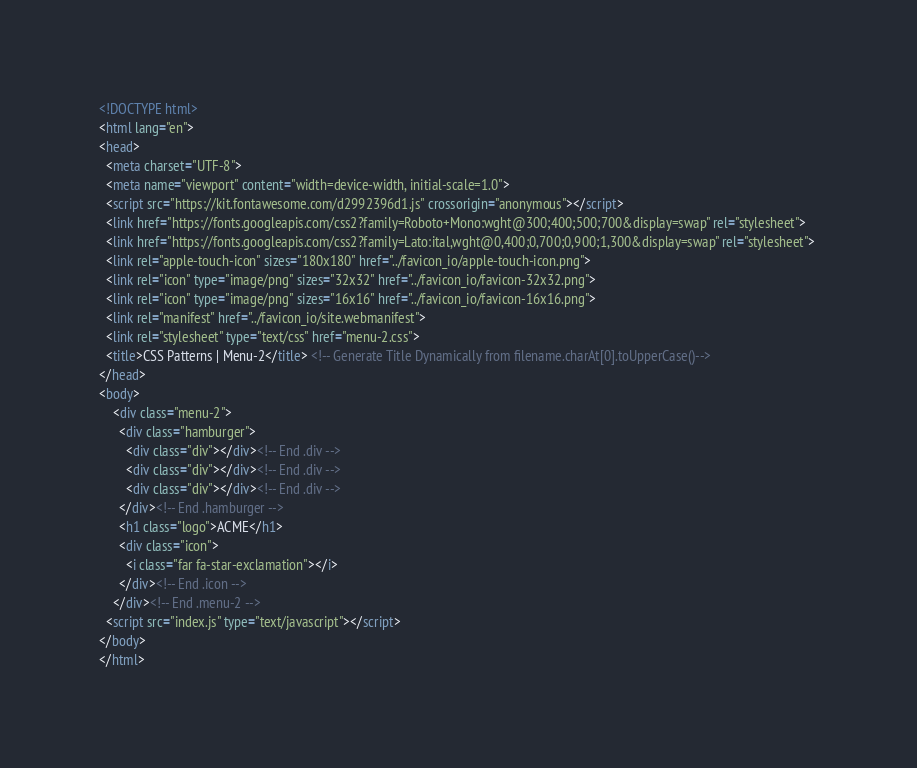<code> <loc_0><loc_0><loc_500><loc_500><_HTML_><!DOCTYPE html>
<html lang="en">
<head>
  <meta charset="UTF-8">
  <meta name="viewport" content="width=device-width, initial-scale=1.0">
  <script src="https://kit.fontawesome.com/d2992396d1.js" crossorigin="anonymous"></script>
  <link href="https://fonts.googleapis.com/css2?family=Roboto+Mono:wght@300;400;500;700&display=swap" rel="stylesheet">
  <link href="https://fonts.googleapis.com/css2?family=Lato:ital,wght@0,400;0,700;0,900;1,300&display=swap" rel="stylesheet"> 
  <link rel="apple-touch-icon" sizes="180x180" href="../favicon_io/apple-touch-icon.png">
  <link rel="icon" type="image/png" sizes="32x32" href="../favicon_io/favicon-32x32.png">
  <link rel="icon" type="image/png" sizes="16x16" href="../favicon_io/favicon-16x16.png">
  <link rel="manifest" href="../favicon_io/site.webmanifest">
  <link rel="stylesheet" type="text/css" href="menu-2.css">
  <title>CSS Patterns | Menu-2</title> <!-- Generate Title Dynamically from filename.charAt[0].toUpperCase()-->
</head>
<body>
    <div class="menu-2">
      <div class="hamburger">
        <div class="div"></div><!-- End .div -->
        <div class="div"></div><!-- End .div -->
        <div class="div"></div><!-- End .div -->
      </div><!-- End .hamburger -->
      <h1 class="logo">ACME</h1>
      <div class="icon">
        <i class="far fa-star-exclamation"></i>
      </div><!-- End .icon -->
    </div><!-- End .menu-2 -->
  <script src="index.js" type="text/javascript"></script>
</body>
</html></code> 